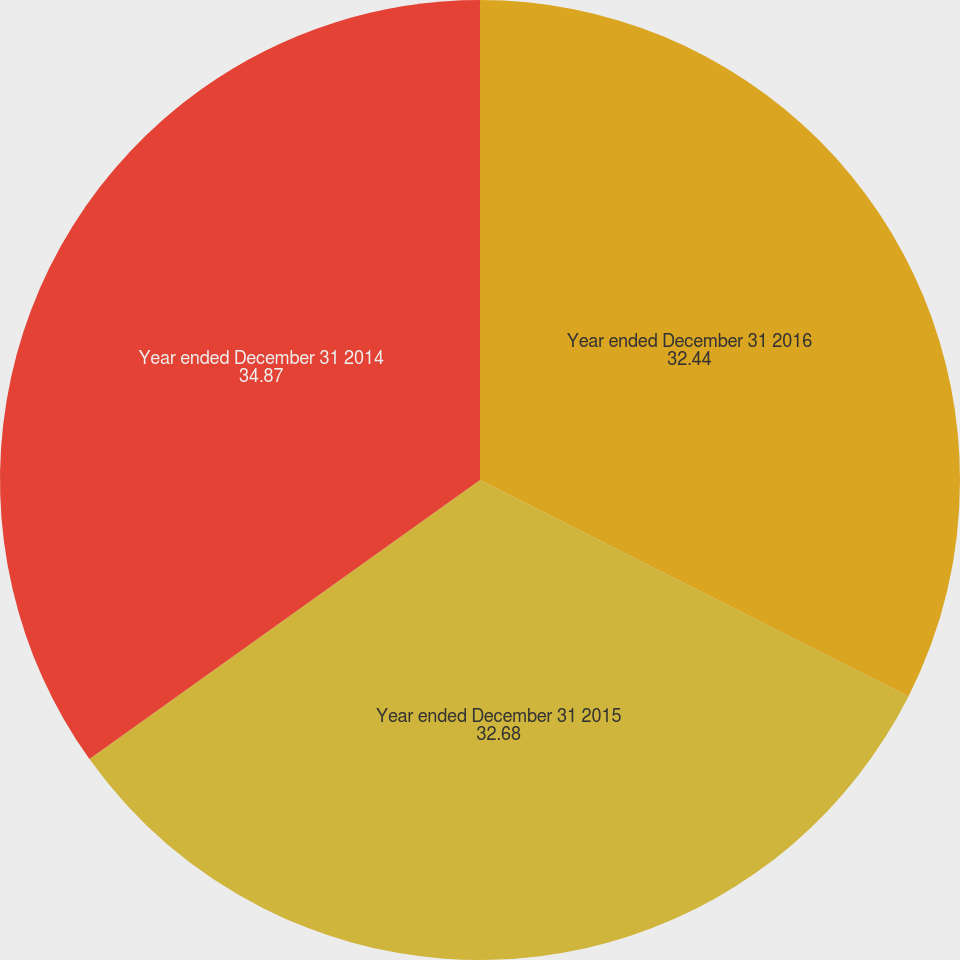Convert chart. <chart><loc_0><loc_0><loc_500><loc_500><pie_chart><fcel>Year ended December 31 2016<fcel>Year ended December 31 2015<fcel>Year ended December 31 2014<nl><fcel>32.44%<fcel>32.68%<fcel>34.87%<nl></chart> 